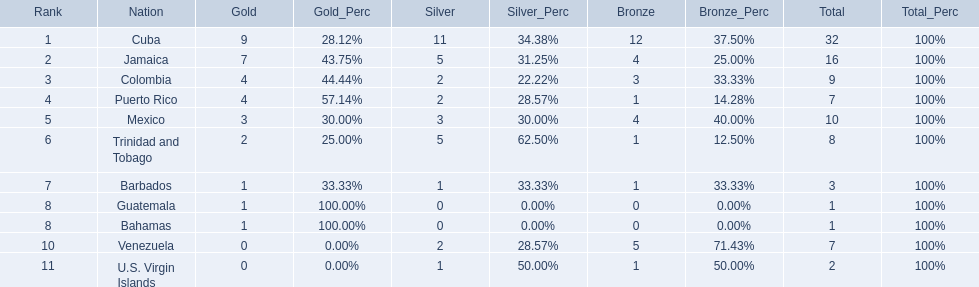Which countries competed in the 1966 central american and caribbean games? Cuba, Jamaica, Colombia, Puerto Rico, Mexico, Trinidad and Tobago, Barbados, Guatemala, Bahamas, Venezuela, U.S. Virgin Islands. Which countries won at least six silver medals at these games? Cuba. 